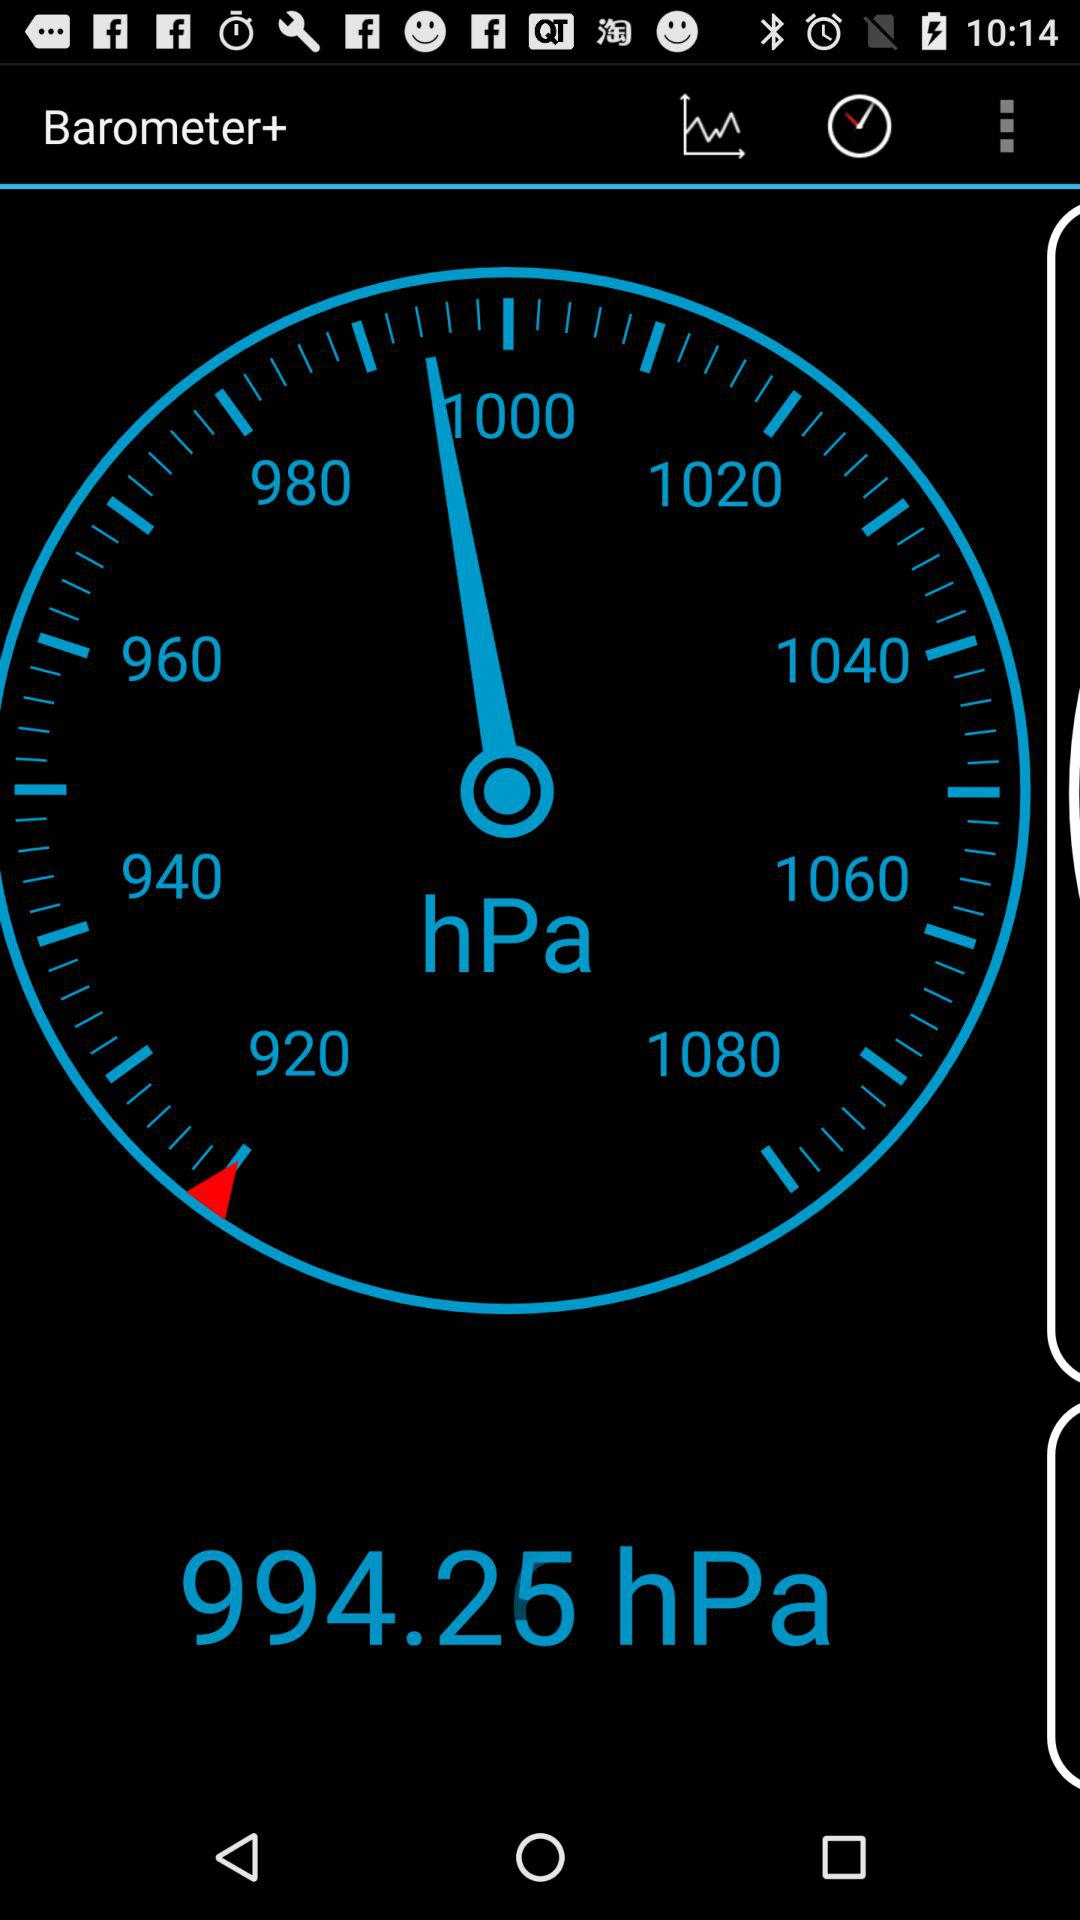What does the graph show?
When the provided information is insufficient, respond with <no answer>. <no answer> 